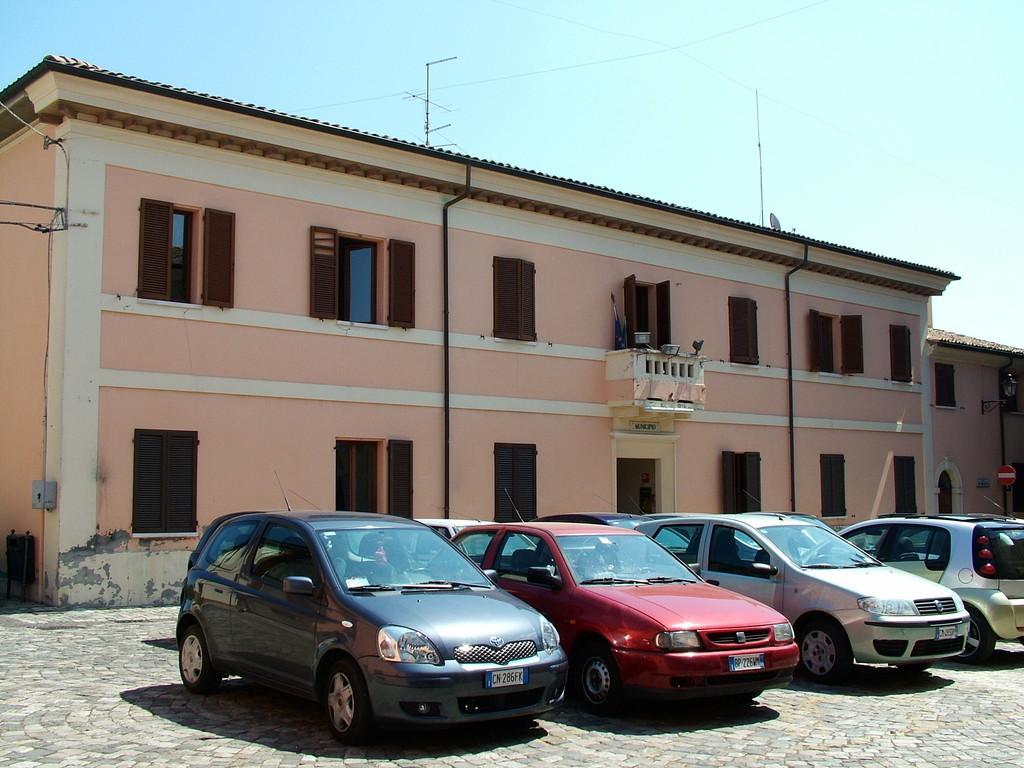How would you summarize this image in a sentence or two? In this picture I can see there are cars parked in a straight line and in the backdrop there is a building and the sky is clear. 